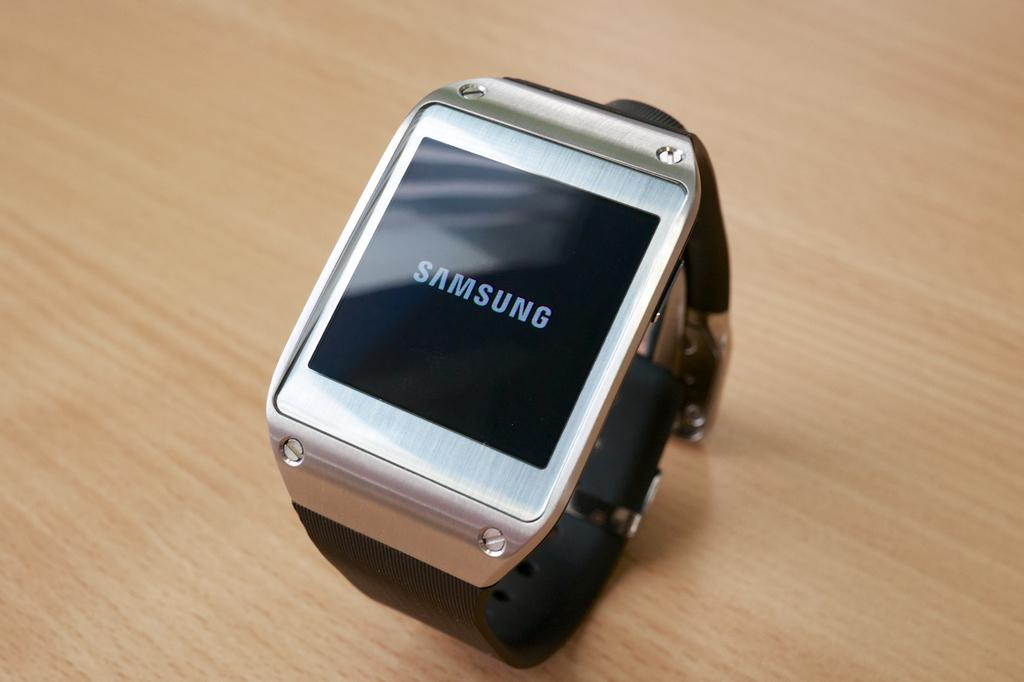<image>
Write a terse but informative summary of the picture. A black and silver Samsung smart watch sitting on a wooden table. 